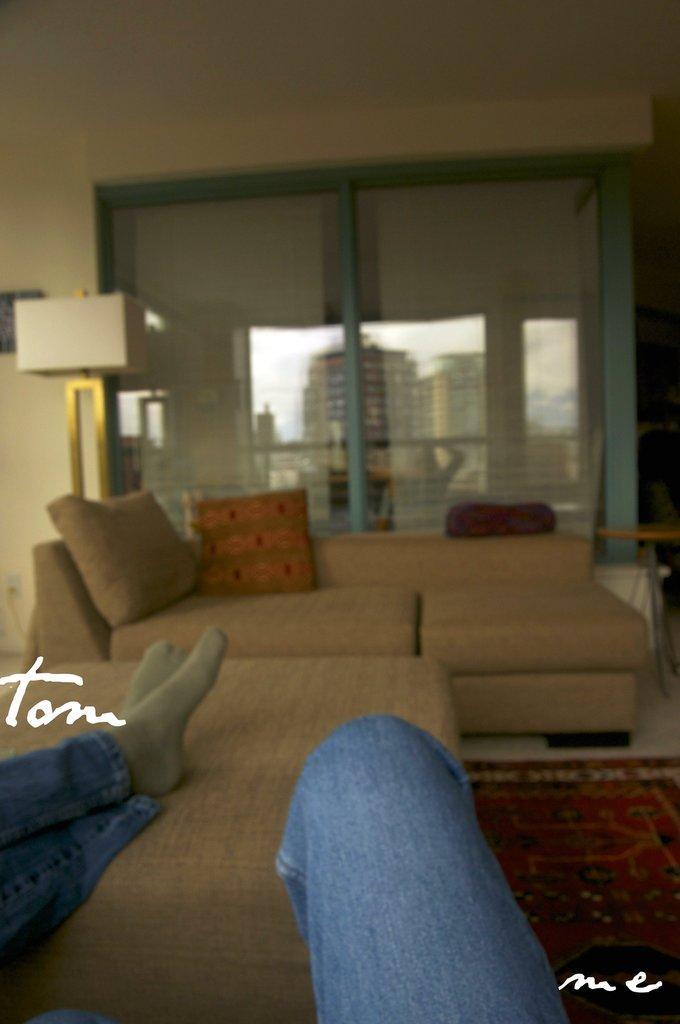How would you summarize this image in a sentence or two? In this picture we can see a room with sofa pillows on it, window and from window we can see buildings here one person leg on bed. 